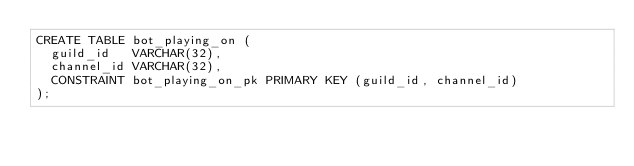<code> <loc_0><loc_0><loc_500><loc_500><_SQL_>CREATE TABLE bot_playing_on (
  guild_id   VARCHAR(32),
  channel_id VARCHAR(32),
  CONSTRAINT bot_playing_on_pk PRIMARY KEY (guild_id, channel_id)
);</code> 